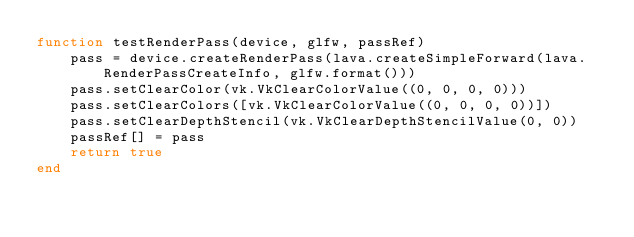<code> <loc_0><loc_0><loc_500><loc_500><_Julia_>function testRenderPass(device, glfw, passRef)
    pass = device.createRenderPass(lava.createSimpleForward(lava.RenderPassCreateInfo, glfw.format()))
    pass.setClearColor(vk.VkClearColorValue((0, 0, 0, 0)))
    pass.setClearColors([vk.VkClearColorValue((0, 0, 0, 0))])
    pass.setClearDepthStencil(vk.VkClearDepthStencilValue(0, 0))
    passRef[] = pass
    return true
end
</code> 